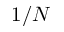<formula> <loc_0><loc_0><loc_500><loc_500>1 / N</formula> 